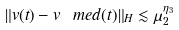<formula> <loc_0><loc_0><loc_500><loc_500>\| v ( t ) - v _ { \ } m e d ( t ) \| _ { H } \lesssim \mu _ { 2 } ^ { \eta _ { 3 } }</formula> 